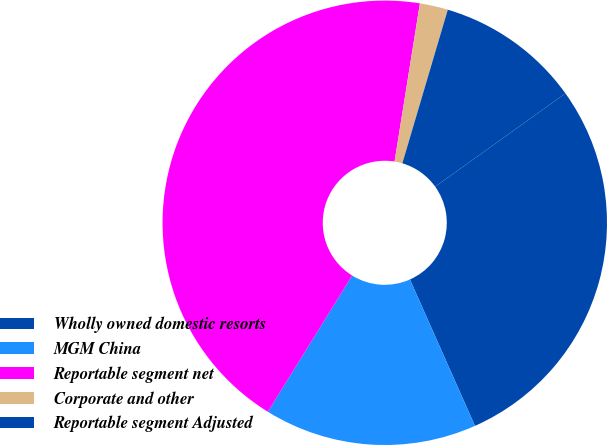<chart> <loc_0><loc_0><loc_500><loc_500><pie_chart><fcel>Wholly owned domestic resorts<fcel>MGM China<fcel>Reportable segment net<fcel>Corporate and other<fcel>Reportable segment Adjusted<nl><fcel>28.24%<fcel>15.47%<fcel>43.71%<fcel>2.05%<fcel>10.53%<nl></chart> 